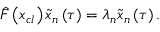<formula> <loc_0><loc_0><loc_500><loc_500>\hat { F } \left ( x _ { c l } \right ) \tilde { x } _ { n } \left ( \tau \right ) = \lambda _ { n } \tilde { x } _ { n } \left ( \tau \right ) .</formula> 